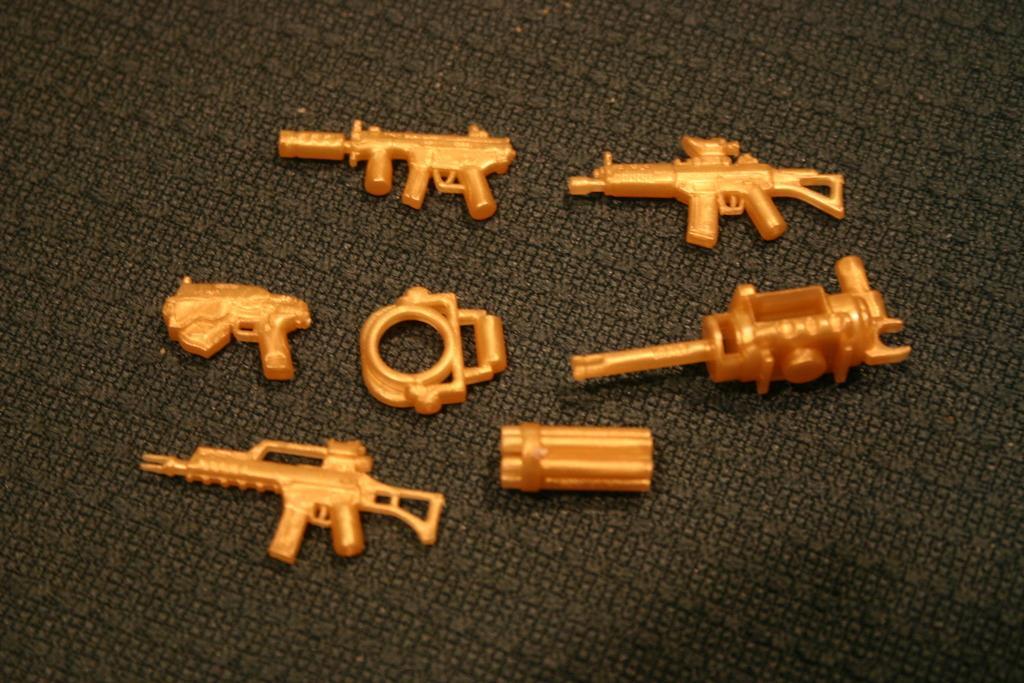Could you give a brief overview of what you see in this image? In this image we can see there are toys on the cloth. 